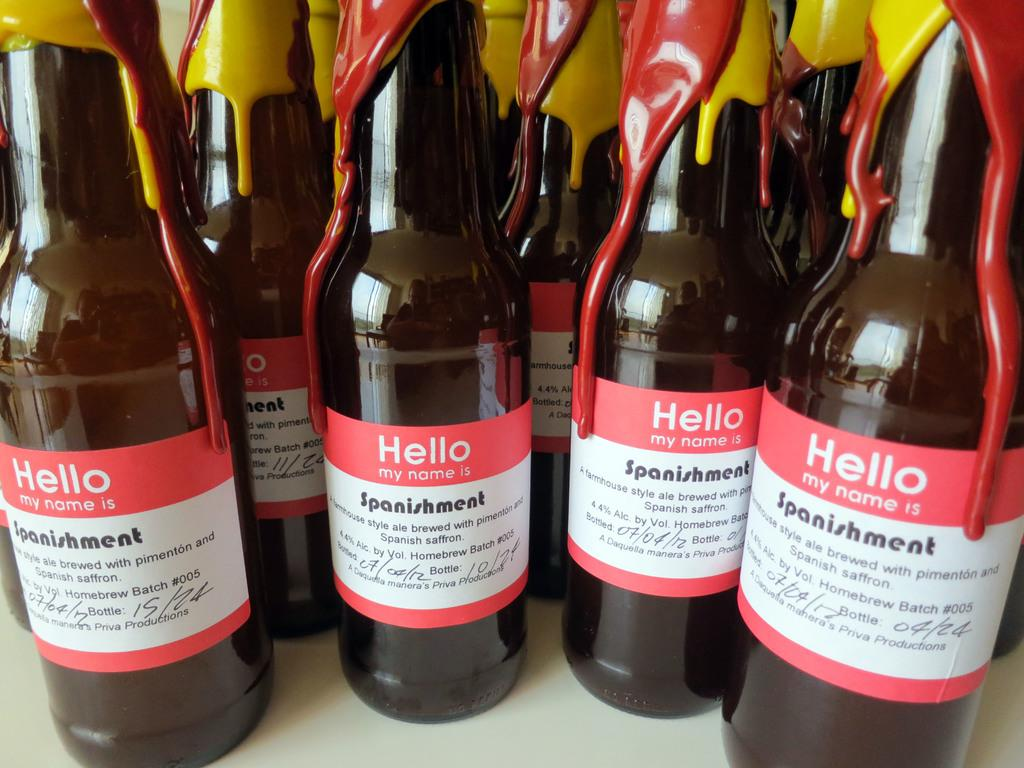What type of beverage containers are present in the image? There are beer bottles in the image. What can be found on the surface of the beer bottles? The beer bottles have labels on them. Where is the playground located in the image? There is no playground present in the image. What type of net can be seen surrounding the beer bottles? There is no net surrounding the beer bottles in the image. 